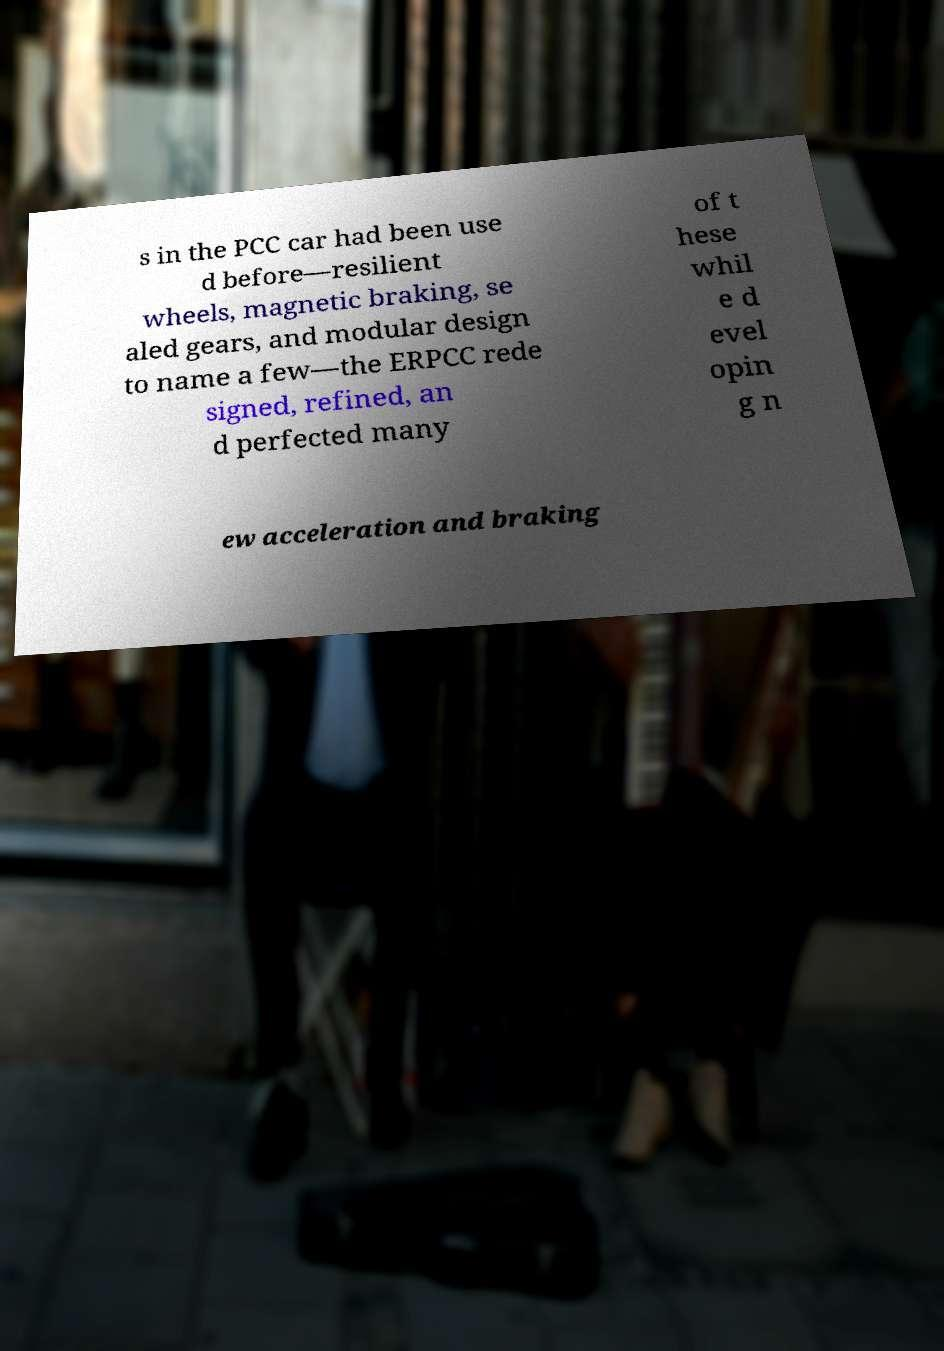Please read and relay the text visible in this image. What does it say? s in the PCC car had been use d before—resilient wheels, magnetic braking, se aled gears, and modular design to name a few—the ERPCC rede signed, refined, an d perfected many of t hese whil e d evel opin g n ew acceleration and braking 